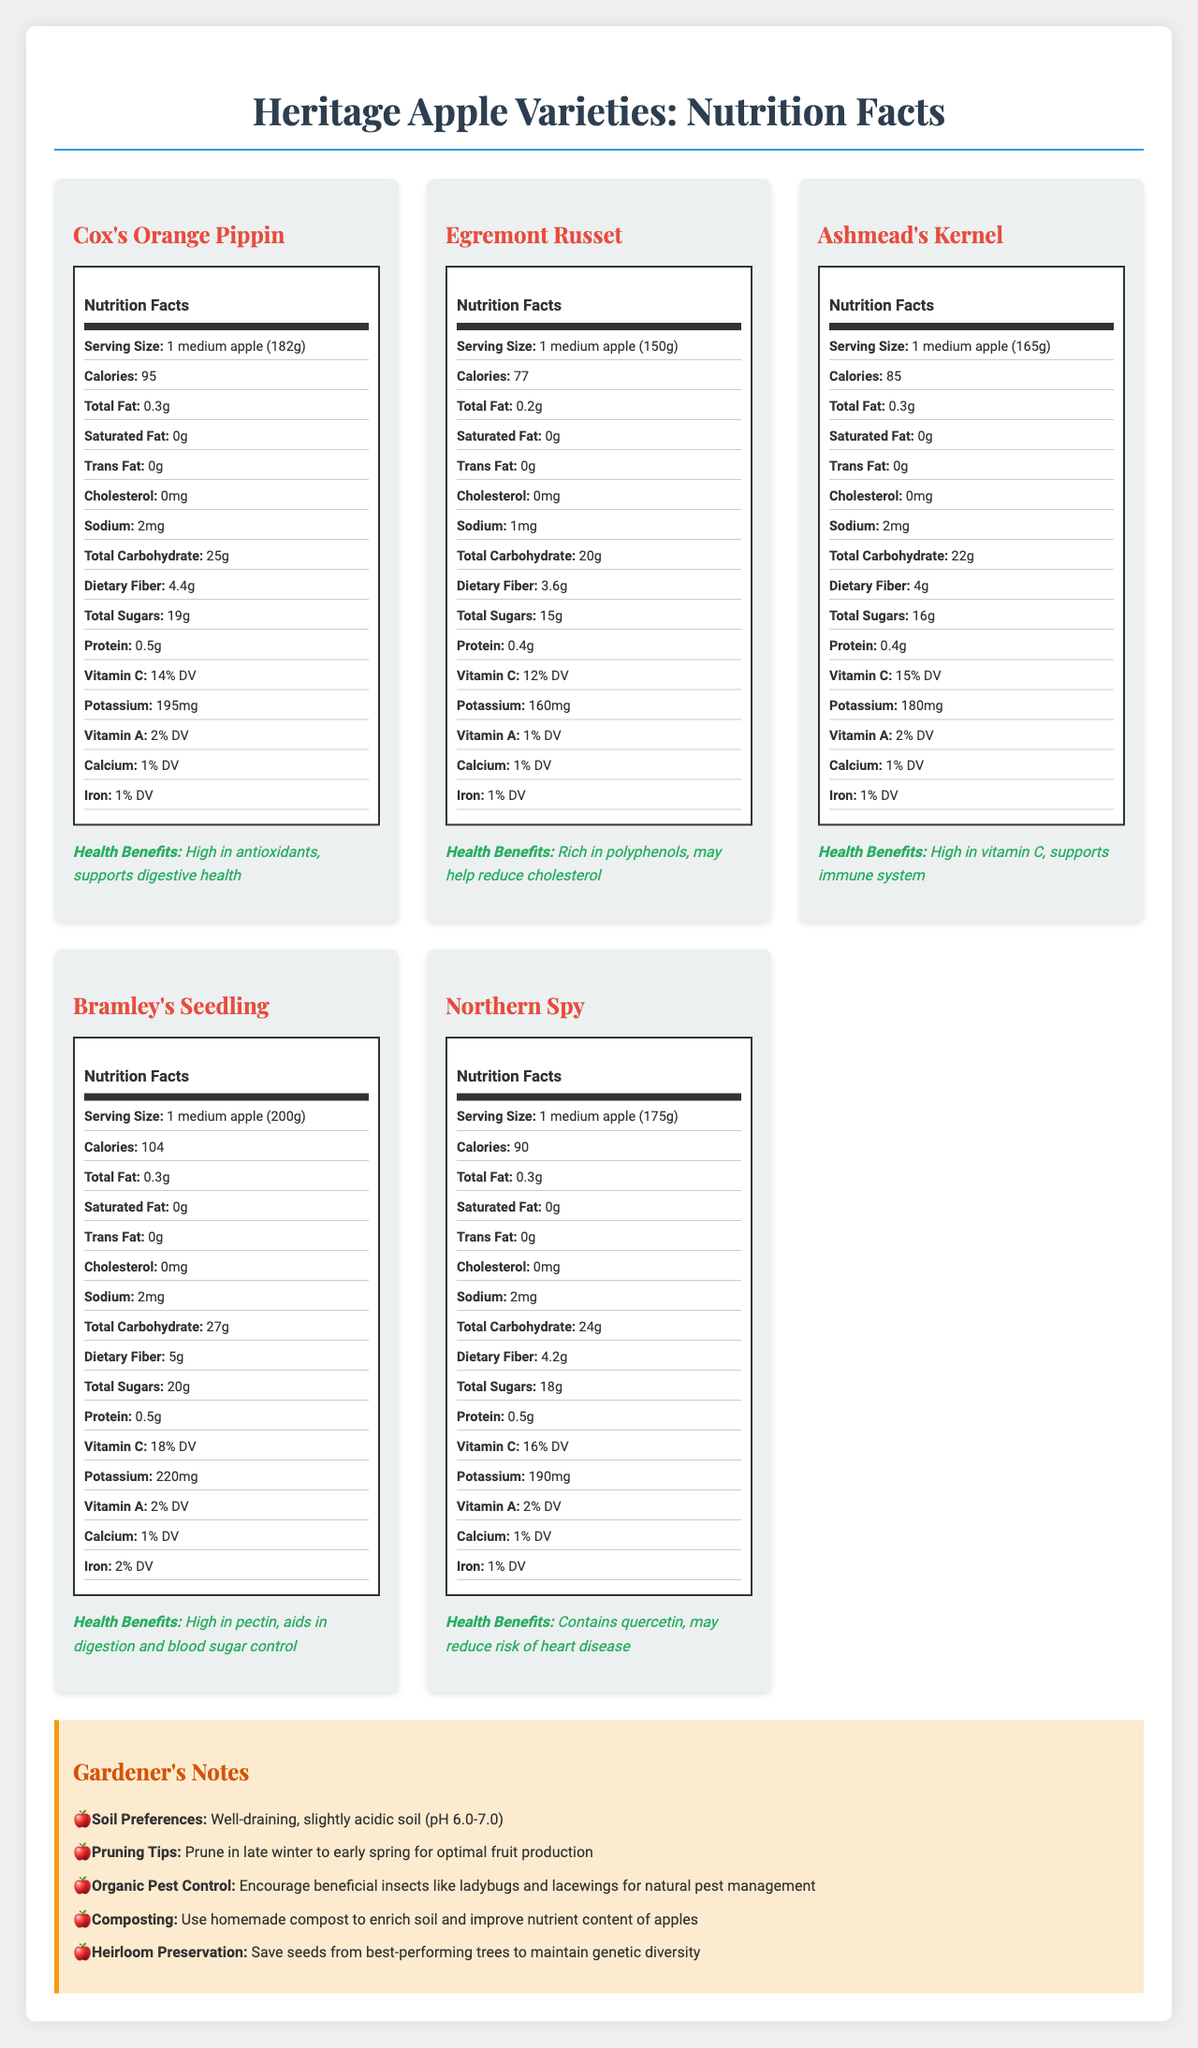what is the serving size for Cox's Orange Pippin? The document under the Cox's Orange Pippin heading lists the serving size as 1 medium apple (182g).
Answer: 1 medium apple (182g) how many calories does an Egremont Russet apple contain? The nutrition facts for Egremont Russet indicate the apple contains 77 calories.
Answer: 77 which variety has the highest potassium content? A. Cox's Orange Pippin B. Egremont Russet C. Ashmead's Kernel D. Bramley's Seedling E. Northern Spy The potassium content for Bramley's Seedling is 220mg, which is the highest among the listed varieties.
Answer: D does Ashmead's Kernel support the immune system? (yes/no) Ashmead's Kernel is noted for being high in vitamin C, which supports the immune system.
Answer: Yes which apple has the highest dietary fiber? According to the nutrition facts, Bramley's Seedling has 5g of dietary fiber, the highest among all listed apples.
Answer: Bramley's Seedling what health benefit is associated with Cox's Orange Pippin? The document lists that Cox's Orange Pippin is high in antioxidants and supports digestive health.
Answer: High in antioxidants, supports digestive health summarize the main nutrients found in Northern Spy. The nutrition facts for Northern Spy detail its key nutrients including calories, fats, cholesterol, sodium, carbohydrates, fiber, sugars, protein, vitamin C, potassium, vitamin A, calcium, and iron.
Answer: Calories: 90, Total Fat: 0.3g, Saturated Fat: 0g, Cholesterol: 0mg, Sodium: 2mg, Total Carbohydrate: 24g, Dietary Fiber: 4.2g, Total Sugars: 18g, Protein: 0.5g, Vitamin C: 16% DV, Potassium: 190mg, Vitamin A: 2% DV, Calcium: 1% DV, Iron: 1% DV. which apple variety is rich in polyphenols? A. Cox's Orange Pippin B. Egremont Russet C. Ashmead's Kernel The health benefits listed for Egremont Russet state it is rich in polyphenols.
Answer: B does Cox's Orange Pippin have trans fat content? The nutrition facts for Cox's Orange Pippin show 0g of trans fat.
Answer: No describe the gardener's notes section. The gardener's notes section includes advice for well-draining, slightly acidic soil, pruning in late winter to early spring, using beneficial insects for pest control, applying homemade compost, and preserving heirloom seeds from top-performing trees.
Answer: The gardener's notes section provides tips for gardening such as soil preferences, pruning tips, organic pest control, composting, and heirloom preservation. what is the vitamin a content in Egremont Russet? The nutrition facts for Egremont Russet list vitamin A content as 1% of the daily value.
Answer: 1% DV which apple has the highest vitamin c content? Bramley's Seedling has the highest vitamin C content at 18% DV as indicated in the document.
Answer: Bramley's Seedling could the document be used to determine the apple variety with the lowest sugar content? By comparing the total sugars listed for each apple variety, one can determine the apple with the lowest sugar content.
Answer: Yes is there information about the flavor profile of the apples? The document focuses on nutritional facts and health benefits, without mentioning the flavor profiles of the apples.
Answer: Not enough information 